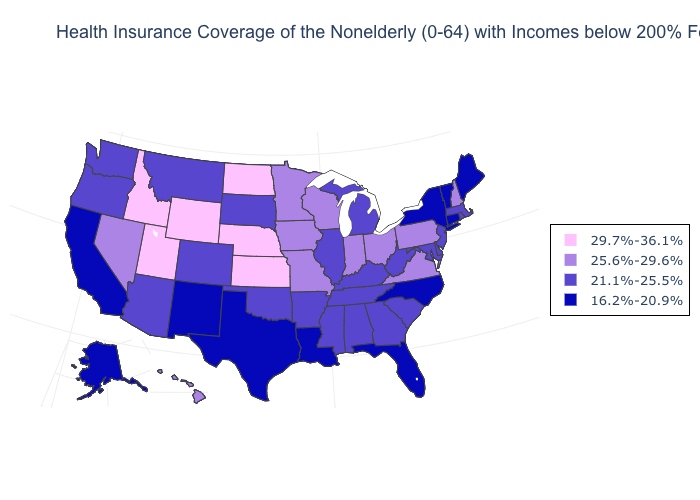Name the states that have a value in the range 21.1%-25.5%?
Write a very short answer. Alabama, Arizona, Arkansas, Colorado, Delaware, Georgia, Illinois, Kentucky, Maryland, Massachusetts, Michigan, Mississippi, Montana, New Jersey, Oklahoma, Oregon, Rhode Island, South Carolina, South Dakota, Tennessee, Washington, West Virginia. What is the value of Ohio?
Concise answer only. 25.6%-29.6%. Does West Virginia have the lowest value in the South?
Keep it brief. No. Does Wyoming have the highest value in the USA?
Answer briefly. Yes. What is the lowest value in the West?
Concise answer only. 16.2%-20.9%. What is the value of Colorado?
Be succinct. 21.1%-25.5%. What is the value of West Virginia?
Quick response, please. 21.1%-25.5%. Name the states that have a value in the range 29.7%-36.1%?
Write a very short answer. Idaho, Kansas, Nebraska, North Dakota, Utah, Wyoming. Does the map have missing data?
Concise answer only. No. Name the states that have a value in the range 16.2%-20.9%?
Answer briefly. Alaska, California, Connecticut, Florida, Louisiana, Maine, New Mexico, New York, North Carolina, Texas, Vermont. Is the legend a continuous bar?
Be succinct. No. Does Oklahoma have the highest value in the USA?
Be succinct. No. What is the value of California?
Keep it brief. 16.2%-20.9%. Name the states that have a value in the range 21.1%-25.5%?
Keep it brief. Alabama, Arizona, Arkansas, Colorado, Delaware, Georgia, Illinois, Kentucky, Maryland, Massachusetts, Michigan, Mississippi, Montana, New Jersey, Oklahoma, Oregon, Rhode Island, South Carolina, South Dakota, Tennessee, Washington, West Virginia. Among the states that border Montana , which have the lowest value?
Concise answer only. South Dakota. 